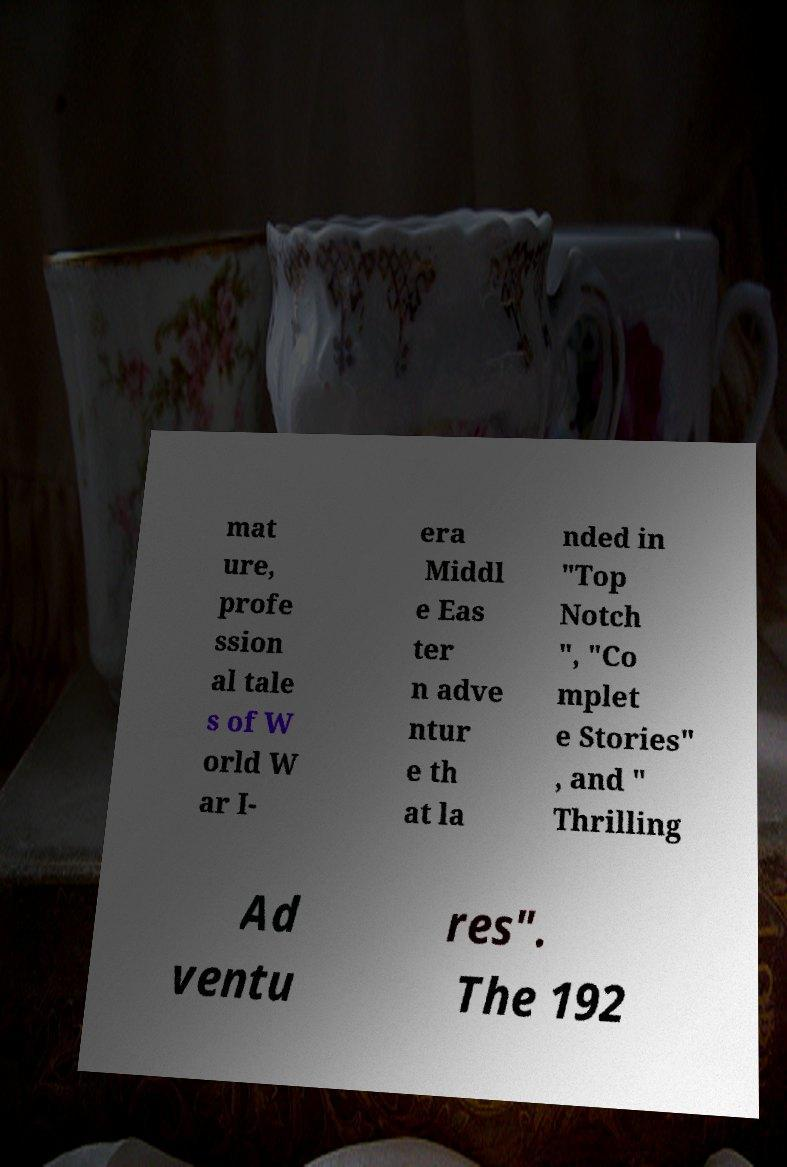Could you extract and type out the text from this image? mat ure, profe ssion al tale s of W orld W ar I- era Middl e Eas ter n adve ntur e th at la nded in "Top Notch ", "Co mplet e Stories" , and " Thrilling Ad ventu res". The 192 